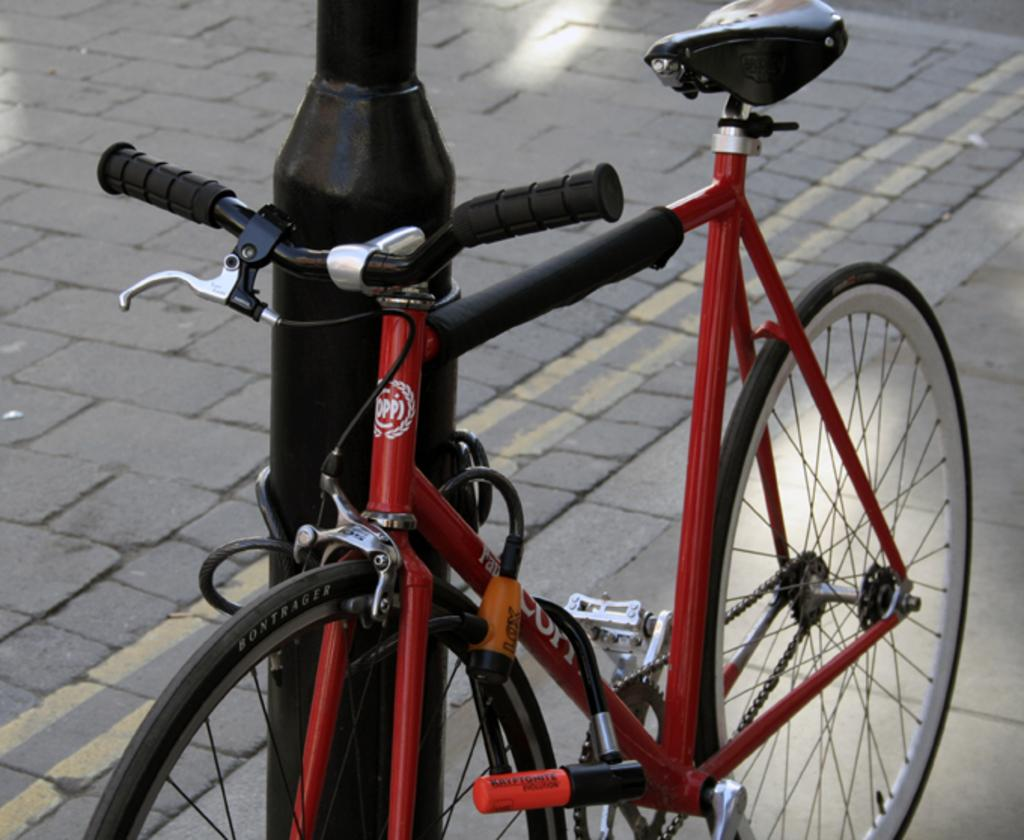What is the main object in the image? There is a bicycle in the image. What other object can be seen on the surface in the image? There is a pole on the surface in the image. What type of haircut is the bicycle getting in the image? The bicycle is not getting a haircut in the image, as it is an inanimate object and haircuts are a service provided to living beings. 